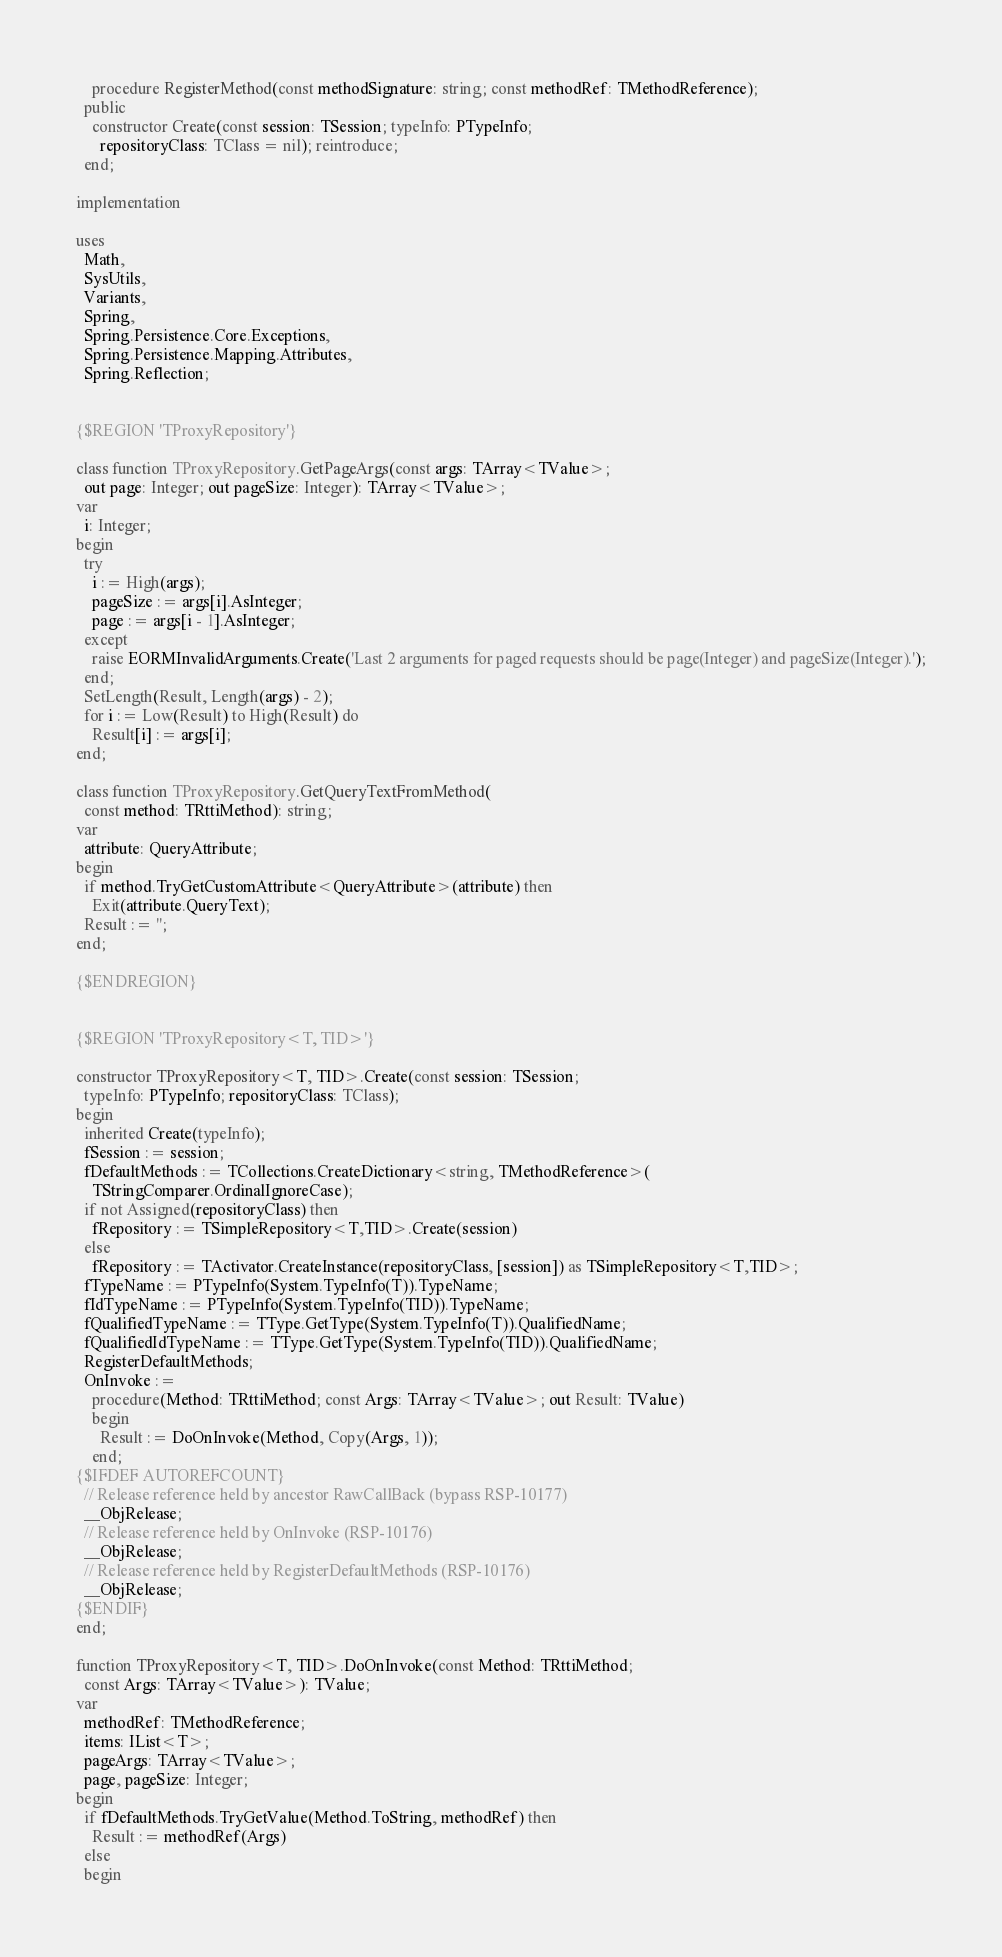Convert code to text. <code><loc_0><loc_0><loc_500><loc_500><_Pascal_>    procedure RegisterMethod(const methodSignature: string; const methodRef: TMethodReference);
  public
    constructor Create(const session: TSession; typeInfo: PTypeInfo;
      repositoryClass: TClass = nil); reintroduce;
  end;

implementation

uses
  Math,
  SysUtils,
  Variants,
  Spring,
  Spring.Persistence.Core.Exceptions,
  Spring.Persistence.Mapping.Attributes,
  Spring.Reflection;


{$REGION 'TProxyRepository'}

class function TProxyRepository.GetPageArgs(const args: TArray<TValue>;
  out page: Integer; out pageSize: Integer): TArray<TValue>;
var
  i: Integer;
begin
  try
    i := High(args);
    pageSize := args[i].AsInteger;
    page := args[i - 1].AsInteger;
  except
    raise EORMInvalidArguments.Create('Last 2 arguments for paged requests should be page(Integer) and pageSize(Integer).');
  end;
  SetLength(Result, Length(args) - 2);
  for i := Low(Result) to High(Result) do
    Result[i] := args[i];
end;

class function TProxyRepository.GetQueryTextFromMethod(
  const method: TRttiMethod): string;
var
  attribute: QueryAttribute;
begin
  if method.TryGetCustomAttribute<QueryAttribute>(attribute) then
    Exit(attribute.QueryText);
  Result := '';
end;

{$ENDREGION}


{$REGION 'TProxyRepository<T, TID>'}

constructor TProxyRepository<T, TID>.Create(const session: TSession;
  typeInfo: PTypeInfo; repositoryClass: TClass);
begin
  inherited Create(typeInfo);
  fSession := session;
  fDefaultMethods := TCollections.CreateDictionary<string, TMethodReference>(
    TStringComparer.OrdinalIgnoreCase);
  if not Assigned(repositoryClass) then
    fRepository := TSimpleRepository<T,TID>.Create(session)
  else
    fRepository := TActivator.CreateInstance(repositoryClass, [session]) as TSimpleRepository<T,TID>;
  fTypeName := PTypeInfo(System.TypeInfo(T)).TypeName;
  fIdTypeName := PTypeInfo(System.TypeInfo(TID)).TypeName;
  fQualifiedTypeName := TType.GetType(System.TypeInfo(T)).QualifiedName;
  fQualifiedIdTypeName := TType.GetType(System.TypeInfo(TID)).QualifiedName;
  RegisterDefaultMethods;
  OnInvoke :=
    procedure(Method: TRttiMethod; const Args: TArray<TValue>; out Result: TValue)
    begin
      Result := DoOnInvoke(Method, Copy(Args, 1));
    end;
{$IFDEF AUTOREFCOUNT}
  // Release reference held by ancestor RawCallBack (bypass RSP-10177)
  __ObjRelease;
  // Release reference held by OnInvoke (RSP-10176)
  __ObjRelease;
  // Release reference held by RegisterDefaultMethods (RSP-10176)
  __ObjRelease;
{$ENDIF}
end;

function TProxyRepository<T, TID>.DoOnInvoke(const Method: TRttiMethod;
  const Args: TArray<TValue>): TValue;
var
  methodRef: TMethodReference;
  items: IList<T>;
  pageArgs: TArray<TValue>;
  page, pageSize: Integer;
begin
  if fDefaultMethods.TryGetValue(Method.ToString, methodRef) then
    Result := methodRef(Args)
  else
  begin</code> 